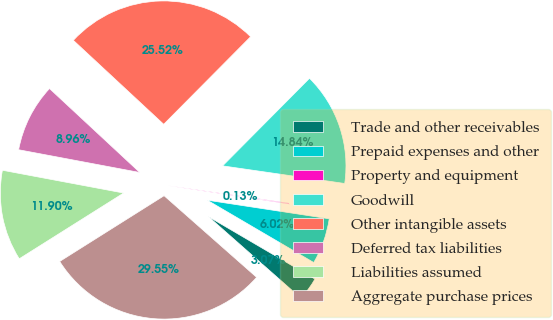<chart> <loc_0><loc_0><loc_500><loc_500><pie_chart><fcel>Trade and other receivables<fcel>Prepaid expenses and other<fcel>Property and equipment<fcel>Goodwill<fcel>Other intangible assets<fcel>Deferred tax liabilities<fcel>Liabilities assumed<fcel>Aggregate purchase prices<nl><fcel>3.07%<fcel>6.02%<fcel>0.13%<fcel>14.84%<fcel>25.52%<fcel>8.96%<fcel>11.9%<fcel>29.55%<nl></chart> 